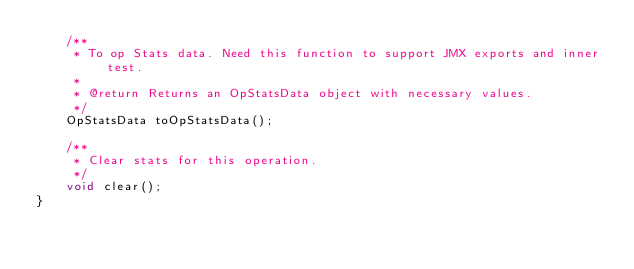Convert code to text. <code><loc_0><loc_0><loc_500><loc_500><_Java_>    /**
     * To op Stats data. Need this function to support JMX exports and inner test.
     *
     * @return Returns an OpStatsData object with necessary values.
     */
    OpStatsData toOpStatsData();

    /**
     * Clear stats for this operation.
     */
    void clear();
}
</code> 